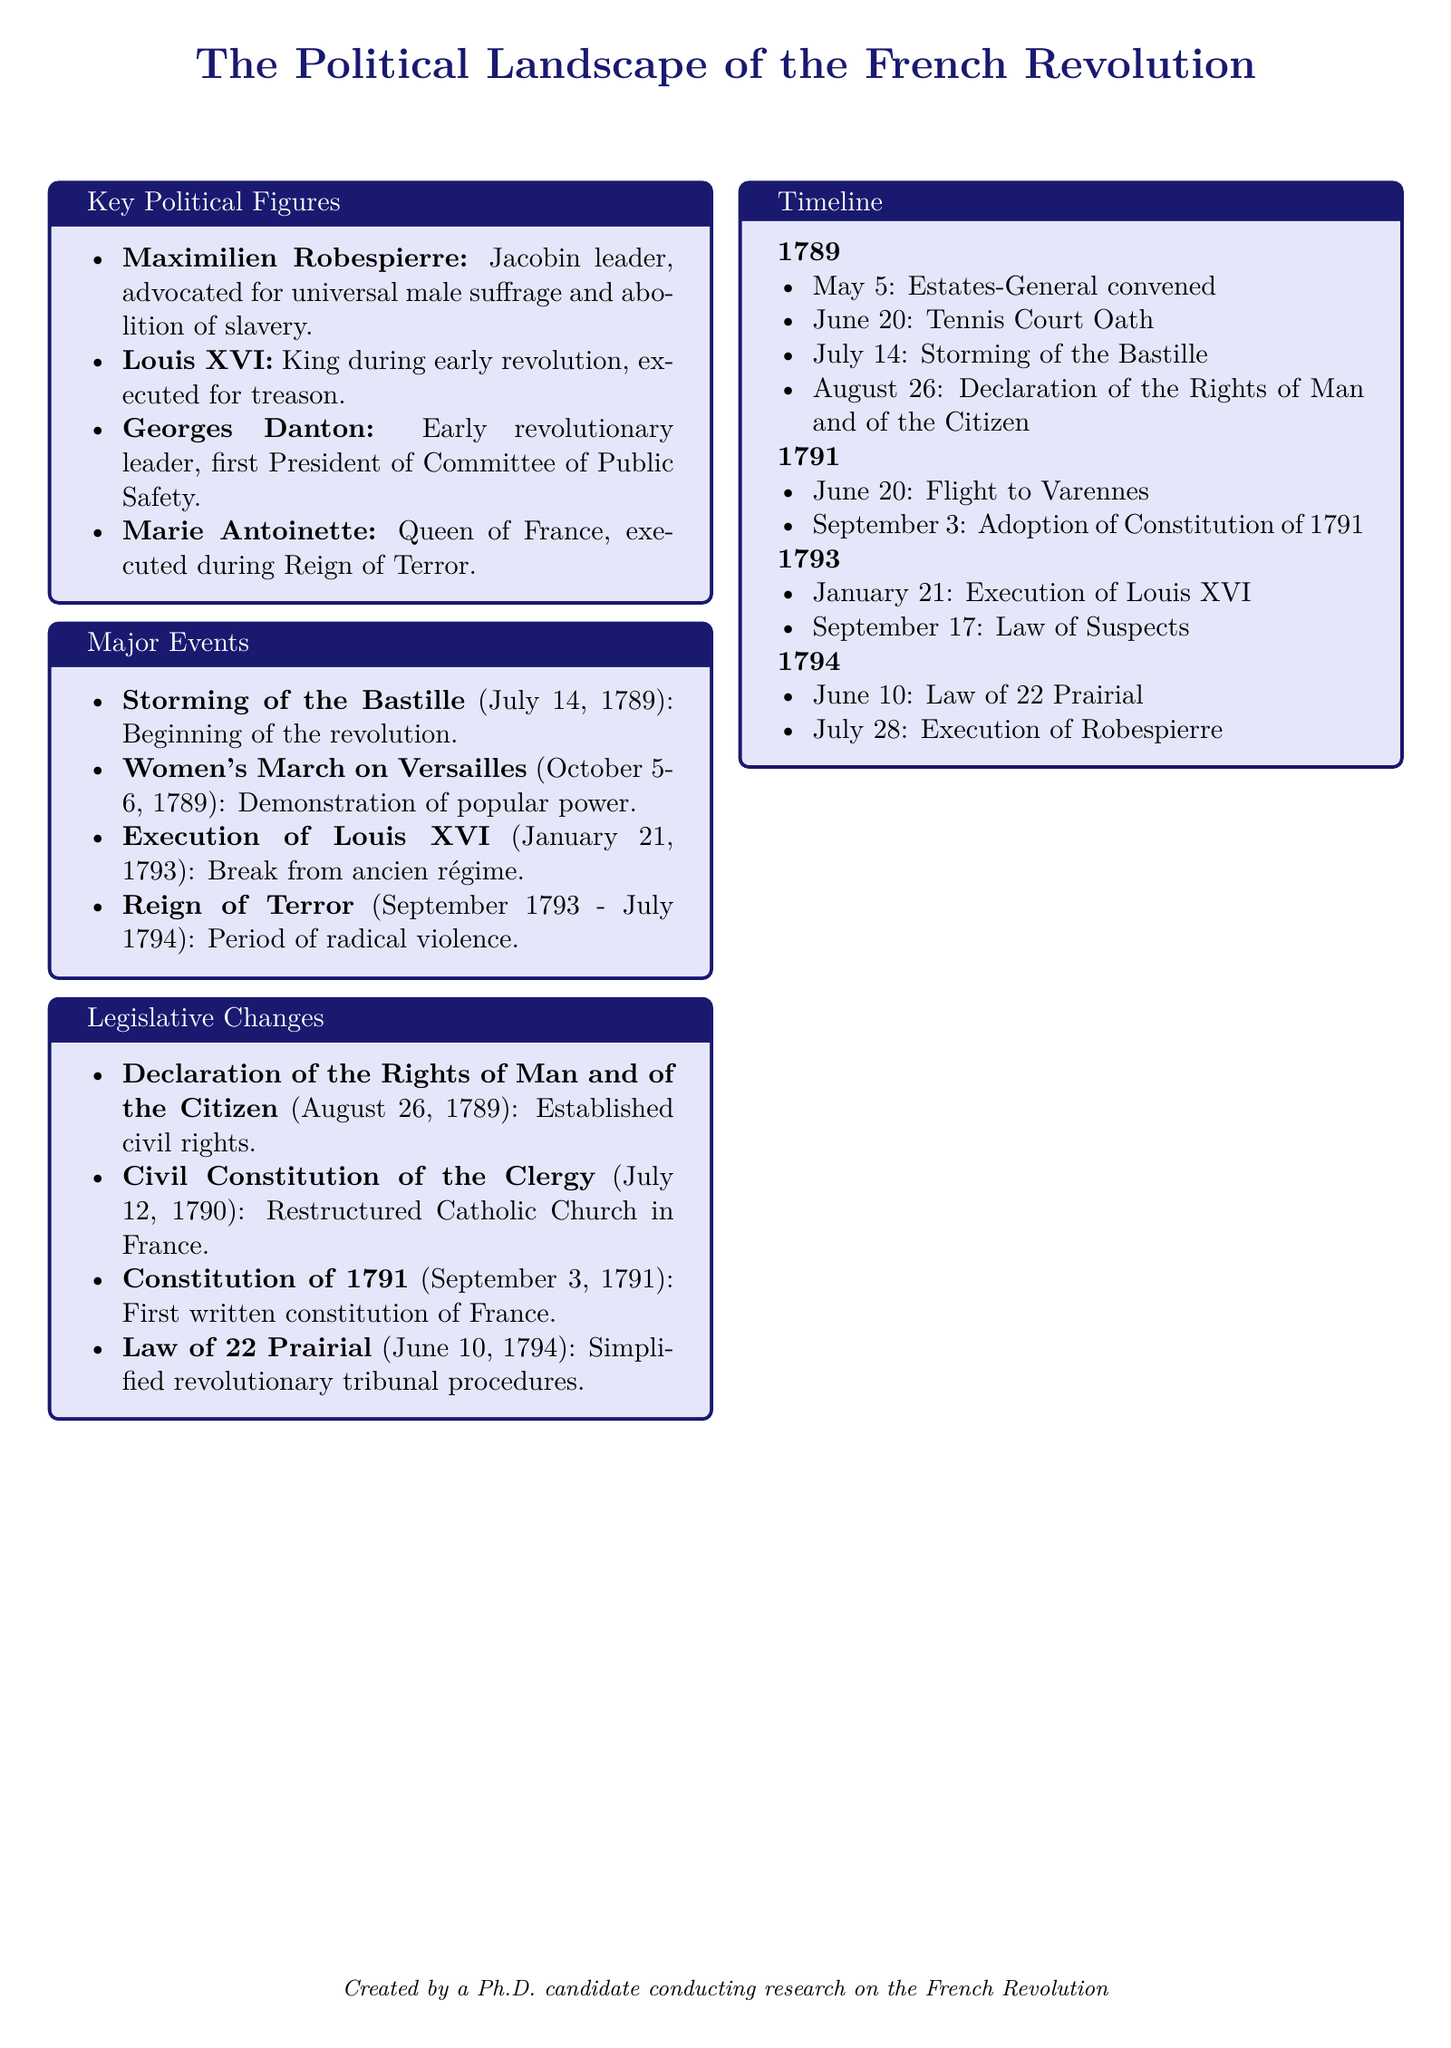what event marks the beginning of the French Revolution? The document states that the Storming of the Bastille on July 14, 1789, marks the beginning of the revolution.
Answer: Storming of the Bastille who was the first President of the Committee of Public Safety? According to the document, Georges Danton was the first President of the Committee of Public Safety.
Answer: Georges Danton what major legislative change was adopted on September 3, 1791? The document indicates that the Constitution of 1791 was adopted on September 3, 1791.
Answer: Constitution of 1791 which king was executed for treason? The document notes that Louis XVI was executed for treason.
Answer: Louis XVI what was the period of radical violence during the revolution called? The document describes the Reign of Terror as the period of radical violence.
Answer: Reign of Terror how many key political figures are listed in the document? The document outlines four key political figures within the context provided.
Answer: Four what date did the Women's March on Versailles occur? The document states that the Women's March on Versailles occurred on October 5-6, 1789.
Answer: October 5-6, 1789 which legislative act restructured the Catholic Church in France? The Civil Constitution of the Clergy, according to the document, restructured the Catholic Church in France.
Answer: Civil Constitution of the Clergy what happened on June 10, 1794? The document states that the Law of 22 Prairial was enacted on June 10, 1794.
Answer: Law of 22 Prairial 